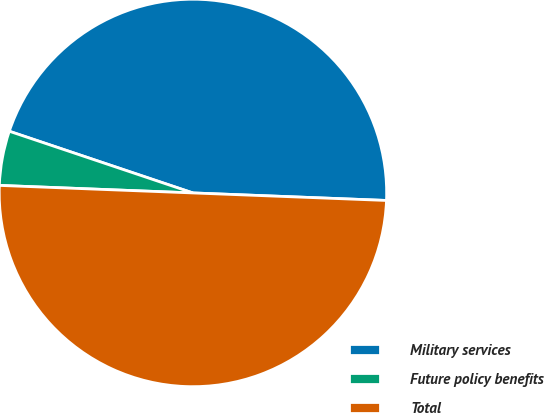Convert chart. <chart><loc_0><loc_0><loc_500><loc_500><pie_chart><fcel>Military services<fcel>Future policy benefits<fcel>Total<nl><fcel>45.46%<fcel>4.54%<fcel>50.0%<nl></chart> 